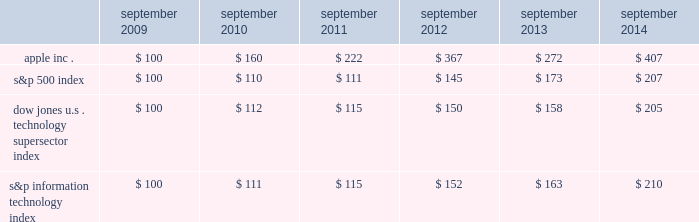Table of contents company stock performance the following graph shows a comparison of cumulative total shareholder return , calculated on a dividend reinvested basis , for the company , the s&p 500 index , the dow jones u.s .
Technology supersector index and the s&p information technology index for the five years ended september 27 , 2014 .
The company has added the s&p information technology index to the graph to capture the stock performance of companies whose products and services relate to those of the company .
The s&p information technology index replaces the s&p computer hardware index , which is no longer tracked by s&p .
The graph assumes $ 100 was invested in each of the company 2019s common stock , the s&p 500 index , the dow jones u.s .
Technology supersector index and the s&p information technology index as of the market close on september 25 , 2009 .
Note that historic stock price performance is not necessarily indicative of future stock price performance .
Copyright a9 2014 s&p , a division of the mcgraw-hill companies inc .
All rights reserved .
Copyright a9 2014 dow jones & co .
All rights reserved .
Apple inc .
| 2014 form 10-k | 23 * $ 100 invested on 9/25/09 in stock or index , including reinvestment of dividends .
Data points are the last day of each fiscal year for the company 2019s common stock and september 30th for indexes .
September september september september september september .

In what year did the s&p 500 have the greatest return? 
Computations: table_max(s&p 500 index, none)
Answer: 207.0. 